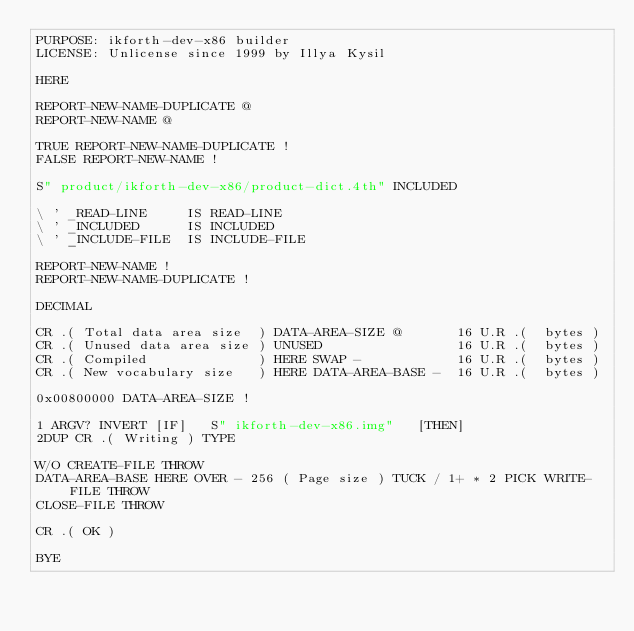<code> <loc_0><loc_0><loc_500><loc_500><_Forth_>PURPOSE: ikforth-dev-x86 builder
LICENSE: Unlicense since 1999 by Illya Kysil

HERE

REPORT-NEW-NAME-DUPLICATE @
REPORT-NEW-NAME @

TRUE REPORT-NEW-NAME-DUPLICATE !
FALSE REPORT-NEW-NAME !

S" product/ikforth-dev-x86/product-dict.4th" INCLUDED

\ ' _READ-LINE     IS READ-LINE
\ ' _INCLUDED      IS INCLUDED
\ ' _INCLUDE-FILE  IS INCLUDE-FILE

REPORT-NEW-NAME !
REPORT-NEW-NAME-DUPLICATE !

DECIMAL

CR .( Total data area size  ) DATA-AREA-SIZE @       16 U.R .(  bytes )
CR .( Unused data area size ) UNUSED                 16 U.R .(  bytes )
CR .( Compiled              ) HERE SWAP -            16 U.R .(  bytes )
CR .( New vocabulary size   ) HERE DATA-AREA-BASE -  16 U.R .(  bytes )

0x00800000 DATA-AREA-SIZE !

1 ARGV? INVERT [IF]   S" ikforth-dev-x86.img"   [THEN]
2DUP CR .( Writing ) TYPE

W/O CREATE-FILE THROW
DATA-AREA-BASE HERE OVER - 256 ( Page size ) TUCK / 1+ * 2 PICK WRITE-FILE THROW
CLOSE-FILE THROW

CR .( OK )

BYE
</code> 